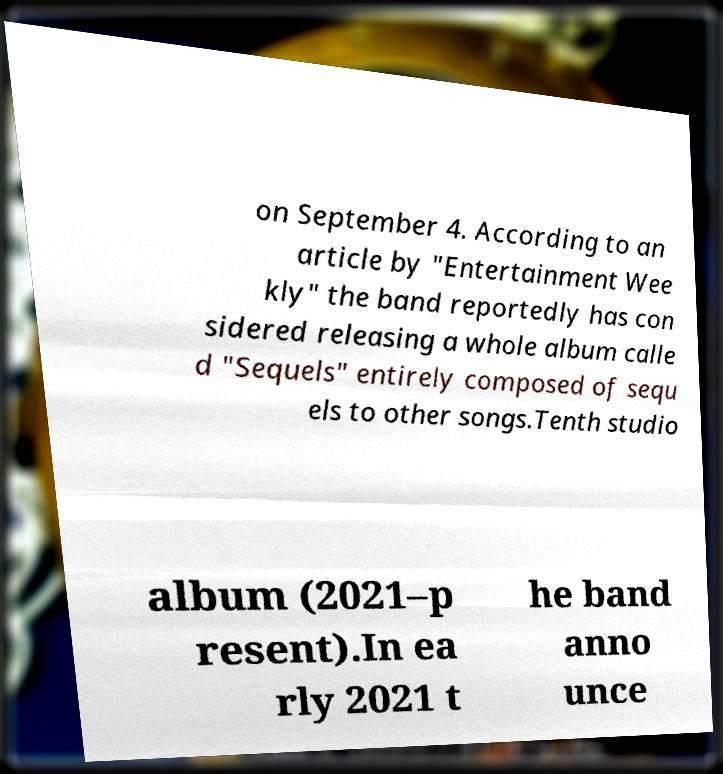Can you read and provide the text displayed in the image?This photo seems to have some interesting text. Can you extract and type it out for me? on September 4. According to an article by "Entertainment Wee kly" the band reportedly has con sidered releasing a whole album calle d "Sequels" entirely composed of sequ els to other songs.Tenth studio album (2021–p resent).In ea rly 2021 t he band anno unce 